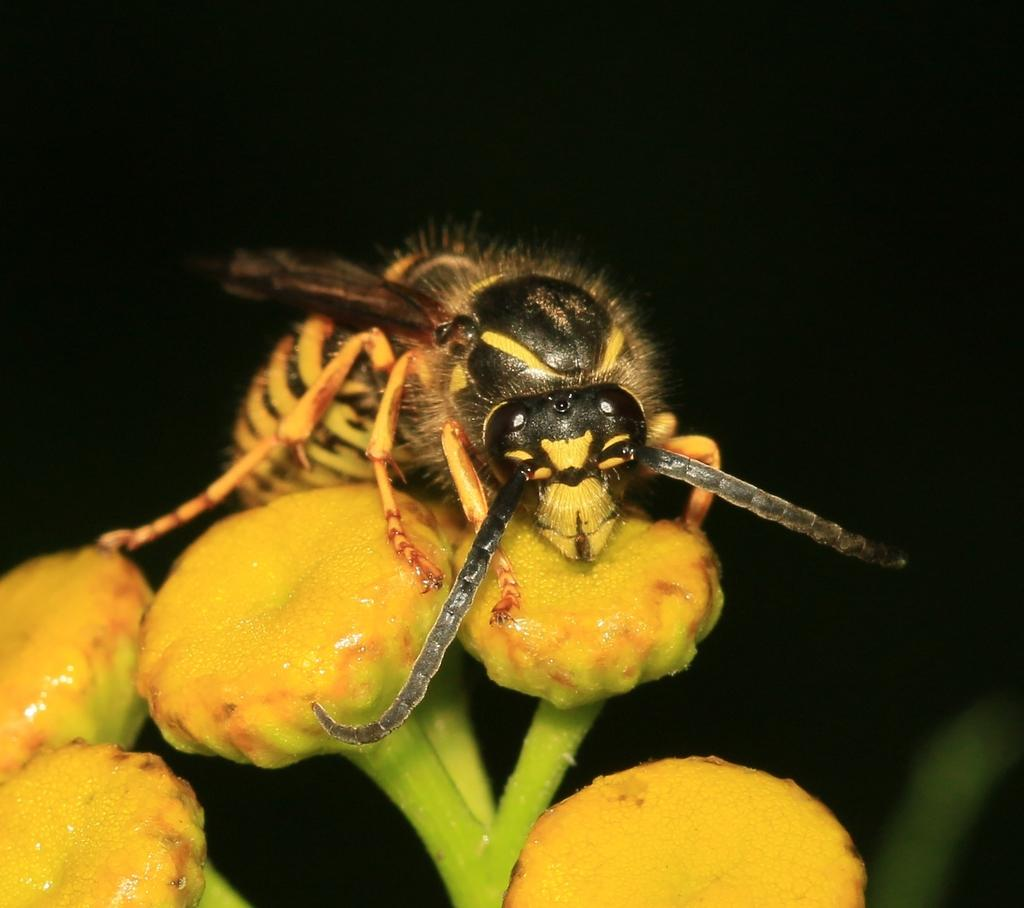What type of creature can be seen in the image? There is an insect in the image. Where is the insect located in the image? The insect is on flower buds. What type of drink is the insect holding in its hands in the image? There is no drink or hands present in the image, as the insect is on flower buds and insects do not have hands. 